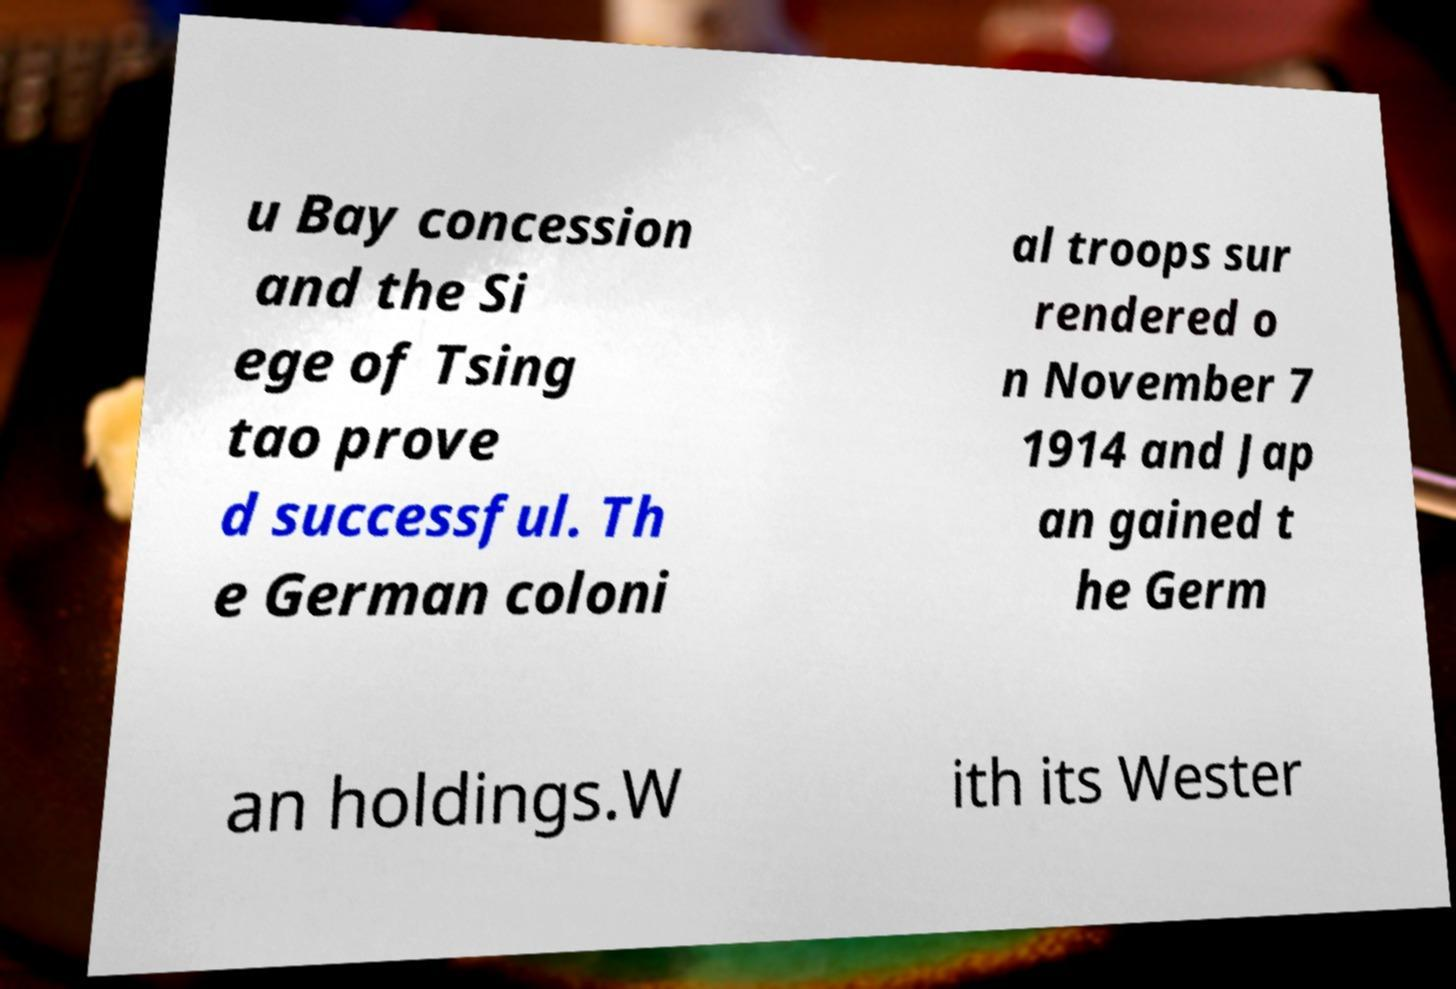Can you accurately transcribe the text from the provided image for me? u Bay concession and the Si ege of Tsing tao prove d successful. Th e German coloni al troops sur rendered o n November 7 1914 and Jap an gained t he Germ an holdings.W ith its Wester 